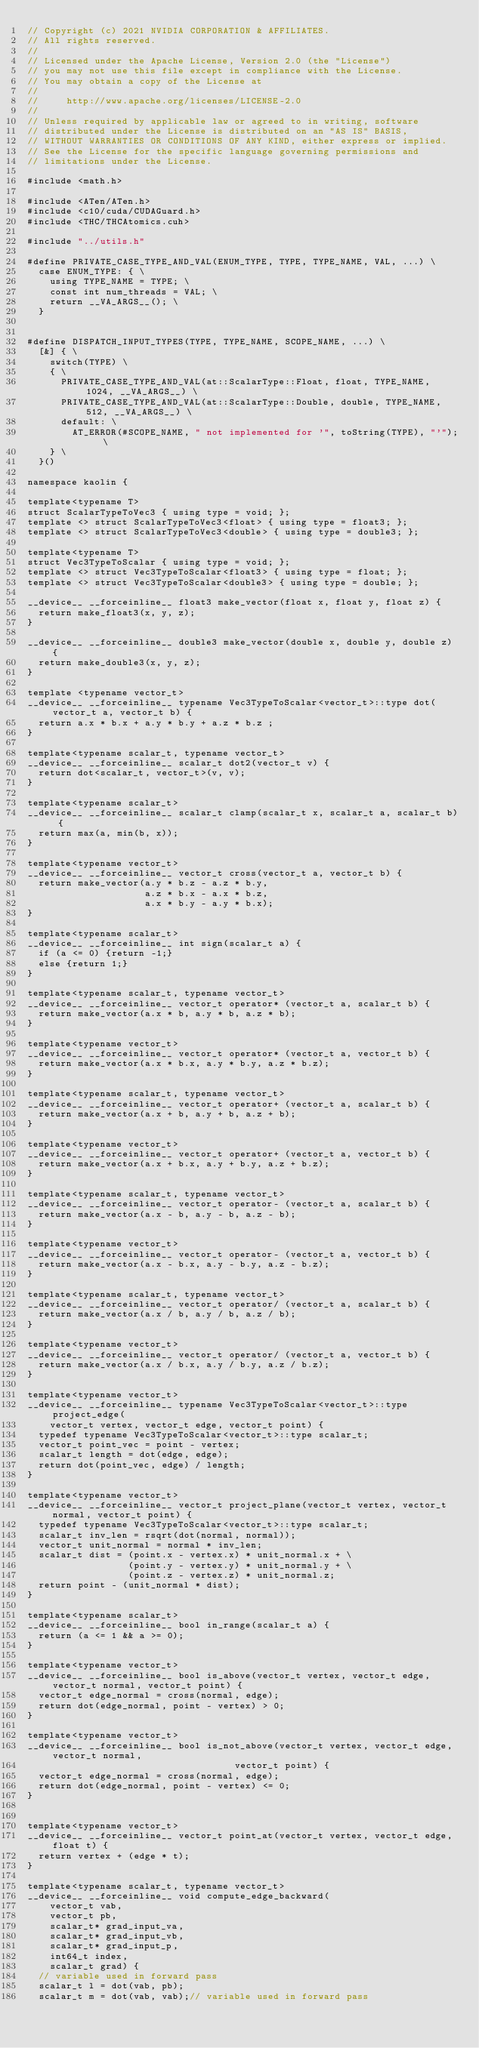<code> <loc_0><loc_0><loc_500><loc_500><_Cuda_>// Copyright (c) 2021 NVIDIA CORPORATION & AFFILIATES.
// All rights reserved.
//
// Licensed under the Apache License, Version 2.0 (the "License")
// you may not use this file except in compliance with the License.
// You may obtain a copy of the License at
//
//     http://www.apache.org/licenses/LICENSE-2.0
//
// Unless required by applicable law or agreed to in writing, software
// distributed under the License is distributed on an "AS IS" BASIS,
// WITHOUT WARRANTIES OR CONDITIONS OF ANY KIND, either express or implied.
// See the License for the specific language governing permissions and
// limitations under the License.

#include <math.h>

#include <ATen/ATen.h>
#include <c10/cuda/CUDAGuard.h>
#include <THC/THCAtomics.cuh>

#include "../utils.h"

#define PRIVATE_CASE_TYPE_AND_VAL(ENUM_TYPE, TYPE, TYPE_NAME, VAL, ...) \
  case ENUM_TYPE: { \
    using TYPE_NAME = TYPE; \
    const int num_threads = VAL; \
    return __VA_ARGS__(); \
  }


#define DISPATCH_INPUT_TYPES(TYPE, TYPE_NAME, SCOPE_NAME, ...) \
  [&] { \
    switch(TYPE) \
    { \
      PRIVATE_CASE_TYPE_AND_VAL(at::ScalarType::Float, float, TYPE_NAME, 1024, __VA_ARGS__) \
      PRIVATE_CASE_TYPE_AND_VAL(at::ScalarType::Double, double, TYPE_NAME, 512, __VA_ARGS__) \
      default: \
        AT_ERROR(#SCOPE_NAME, " not implemented for '", toString(TYPE), "'"); \
    } \
  }()

namespace kaolin {

template<typename T>
struct ScalarTypeToVec3 { using type = void; };
template <> struct ScalarTypeToVec3<float> { using type = float3; };
template <> struct ScalarTypeToVec3<double> { using type = double3; };

template<typename T>
struct Vec3TypeToScalar { using type = void; };
template <> struct Vec3TypeToScalar<float3> { using type = float; };
template <> struct Vec3TypeToScalar<double3> { using type = double; };

__device__ __forceinline__ float3 make_vector(float x, float y, float z) {
  return make_float3(x, y, z);
}

__device__ __forceinline__ double3 make_vector(double x, double y, double z) {
  return make_double3(x, y, z);
}

template <typename vector_t>
__device__ __forceinline__ typename Vec3TypeToScalar<vector_t>::type dot(vector_t a, vector_t b) {
  return a.x * b.x + a.y * b.y + a.z * b.z ;
}

template<typename scalar_t, typename vector_t>
__device__ __forceinline__ scalar_t dot2(vector_t v) {
  return dot<scalar_t, vector_t>(v, v);
}

template<typename scalar_t>
__device__ __forceinline__ scalar_t clamp(scalar_t x, scalar_t a, scalar_t b) {
  return max(a, min(b, x));
}

template<typename vector_t>
__device__ __forceinline__ vector_t cross(vector_t a, vector_t b) {
  return make_vector(a.y * b.z - a.z * b.y,
                     a.z * b.x - a.x * b.z,
                     a.x * b.y - a.y * b.x);
}

template<typename scalar_t>
__device__ __forceinline__ int sign(scalar_t a) {
  if (a <= 0) {return -1;}
  else {return 1;}
}

template<typename scalar_t, typename vector_t>
__device__ __forceinline__ vector_t operator* (vector_t a, scalar_t b) {
  return make_vector(a.x * b, a.y * b, a.z * b);
}

template<typename vector_t>
__device__ __forceinline__ vector_t operator* (vector_t a, vector_t b) {
  return make_vector(a.x * b.x, a.y * b.y, a.z * b.z);
}

template<typename scalar_t, typename vector_t>
__device__ __forceinline__ vector_t operator+ (vector_t a, scalar_t b) {
  return make_vector(a.x + b, a.y + b, a.z + b);
}

template<typename vector_t>
__device__ __forceinline__ vector_t operator+ (vector_t a, vector_t b) {
  return make_vector(a.x + b.x, a.y + b.y, a.z + b.z);
}

template<typename scalar_t, typename vector_t>
__device__ __forceinline__ vector_t operator- (vector_t a, scalar_t b) {
  return make_vector(a.x - b, a.y - b, a.z - b);
}

template<typename vector_t>
__device__ __forceinline__ vector_t operator- (vector_t a, vector_t b) {
  return make_vector(a.x - b.x, a.y - b.y, a.z - b.z);
}

template<typename scalar_t, typename vector_t>
__device__ __forceinline__ vector_t operator/ (vector_t a, scalar_t b) {
  return make_vector(a.x / b, a.y / b, a.z / b);
}

template<typename vector_t>
__device__ __forceinline__ vector_t operator/ (vector_t a, vector_t b) {
  return make_vector(a.x / b.x, a.y / b.y, a.z / b.z);
}

template<typename vector_t>
__device__ __forceinline__ typename Vec3TypeToScalar<vector_t>::type project_edge(
    vector_t vertex, vector_t edge, vector_t point) {
  typedef typename Vec3TypeToScalar<vector_t>::type scalar_t;
  vector_t point_vec = point - vertex;
  scalar_t length = dot(edge, edge);
  return dot(point_vec, edge) / length;
}

template<typename vector_t>
__device__ __forceinline__ vector_t project_plane(vector_t vertex, vector_t normal, vector_t point) {
  typedef typename Vec3TypeToScalar<vector_t>::type scalar_t;
  scalar_t inv_len = rsqrt(dot(normal, normal));
  vector_t unit_normal = normal * inv_len;
  scalar_t dist = (point.x - vertex.x) * unit_normal.x + \
                  (point.y - vertex.y) * unit_normal.y + \
                  (point.z - vertex.z) * unit_normal.z;
  return point - (unit_normal * dist);
}

template<typename scalar_t>
__device__ __forceinline__ bool in_range(scalar_t a) {
  return (a <= 1 && a >= 0);
}

template<typename vector_t>
__device__ __forceinline__ bool is_above(vector_t vertex, vector_t edge, vector_t normal, vector_t point) {
  vector_t edge_normal = cross(normal, edge);
  return dot(edge_normal, point - vertex) > 0;
}

template<typename vector_t>
__device__ __forceinline__ bool is_not_above(vector_t vertex, vector_t edge, vector_t normal,
                                     vector_t point) {
  vector_t edge_normal = cross(normal, edge);
  return dot(edge_normal, point - vertex) <= 0;
}


template<typename vector_t>
__device__ __forceinline__ vector_t point_at(vector_t vertex, vector_t edge, float t) {
  return vertex + (edge * t);
}

template<typename scalar_t, typename vector_t>
__device__ __forceinline__ void compute_edge_backward(
    vector_t vab,
    vector_t pb,
    scalar_t* grad_input_va,
    scalar_t* grad_input_vb,
    scalar_t* grad_input_p,
    int64_t index,
    scalar_t grad) {
  // variable used in forward pass
  scalar_t l = dot(vab, pb);
  scalar_t m = dot(vab, vab);// variable used in forward pass</code> 